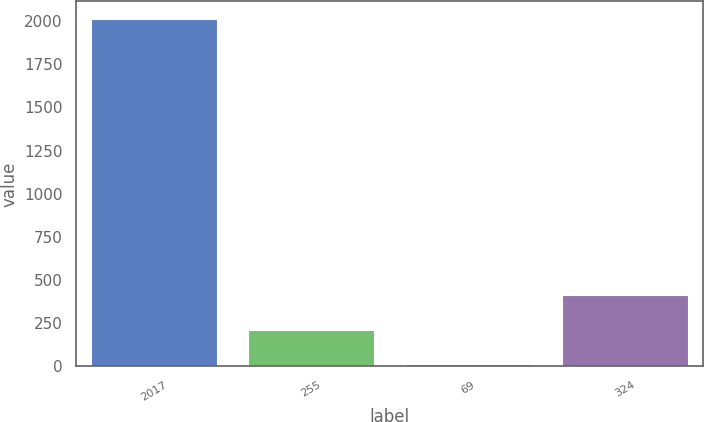<chart> <loc_0><loc_0><loc_500><loc_500><bar_chart><fcel>2017<fcel>255<fcel>69<fcel>324<nl><fcel>2013<fcel>211.47<fcel>11.3<fcel>411.64<nl></chart> 